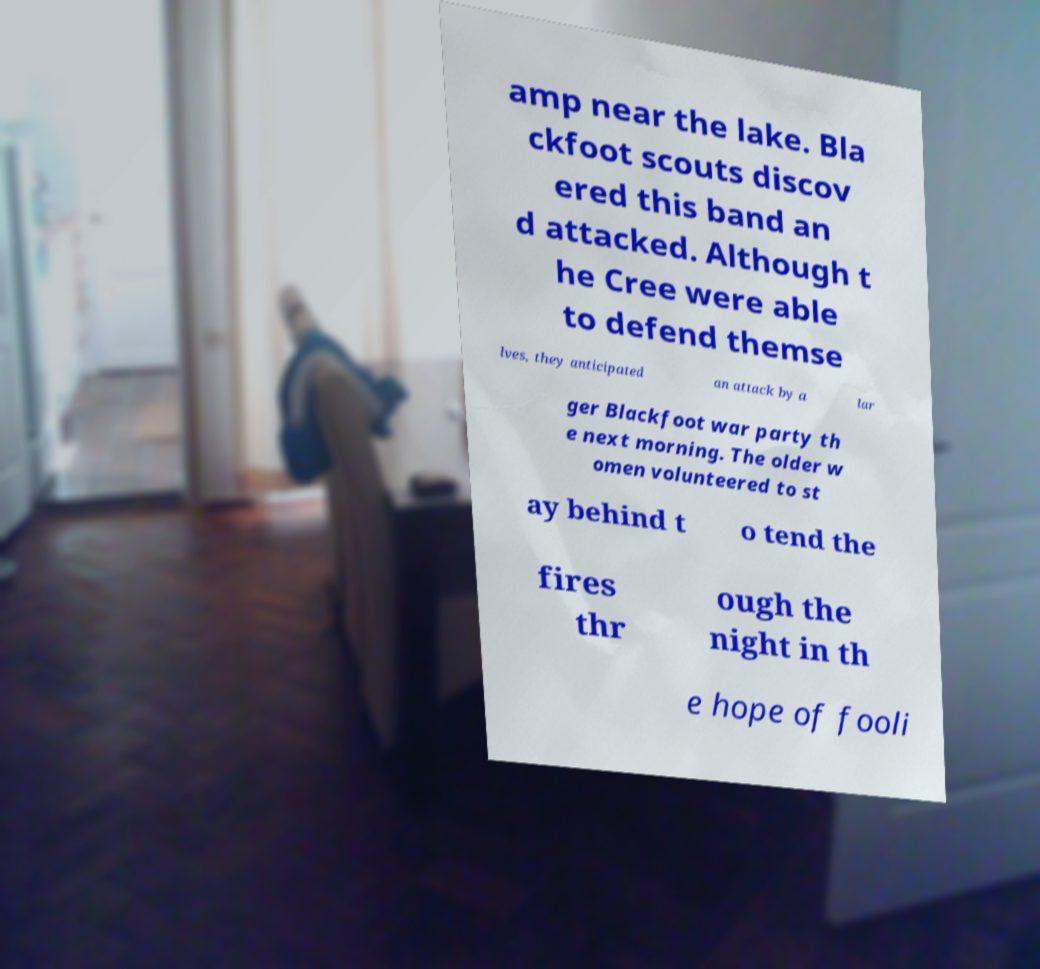Please identify and transcribe the text found in this image. amp near the lake. Bla ckfoot scouts discov ered this band an d attacked. Although t he Cree were able to defend themse lves, they anticipated an attack by a lar ger Blackfoot war party th e next morning. The older w omen volunteered to st ay behind t o tend the fires thr ough the night in th e hope of fooli 